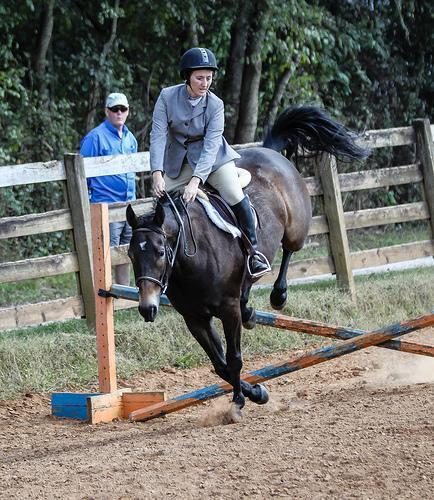How many horses are there?
Give a very brief answer. 1. 